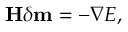<formula> <loc_0><loc_0><loc_500><loc_500>H \delta m = - \nabla E ,</formula> 